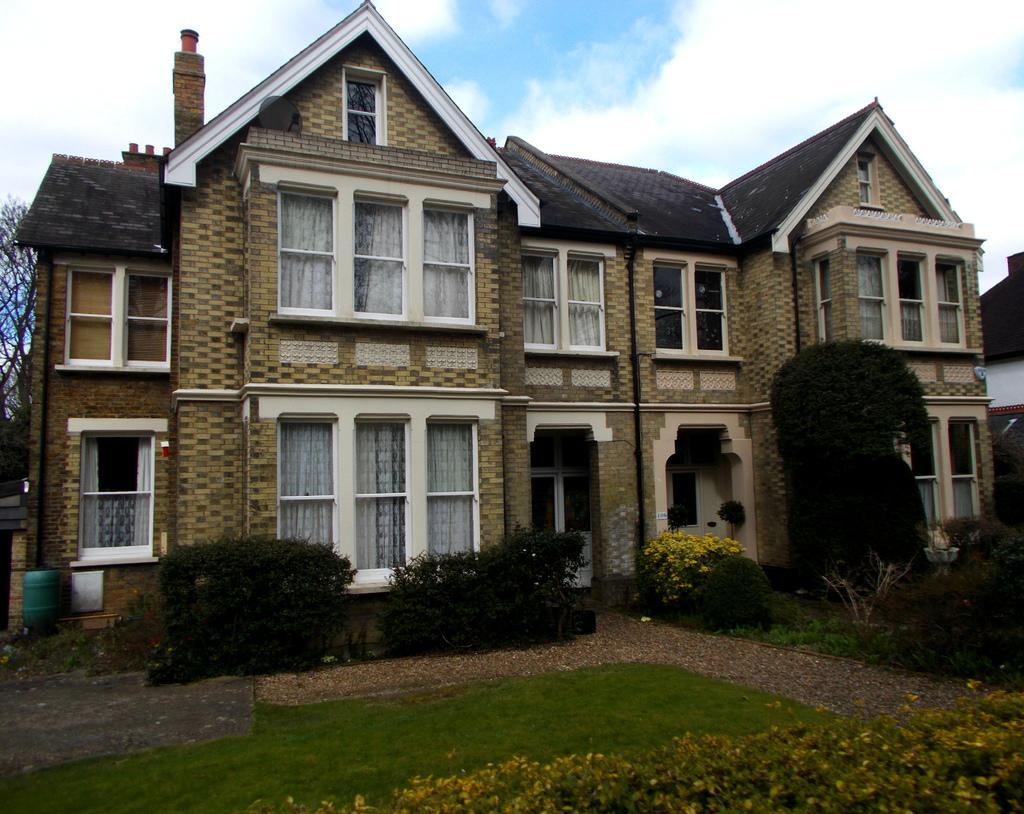What type of structure is visible in the image? There is a house in the image. What can be seen in front of the house? There are plants and a garden in front of the house. What type of parent is present in the image? There is no parent present in the image; it only features a house, plants, and a garden. 